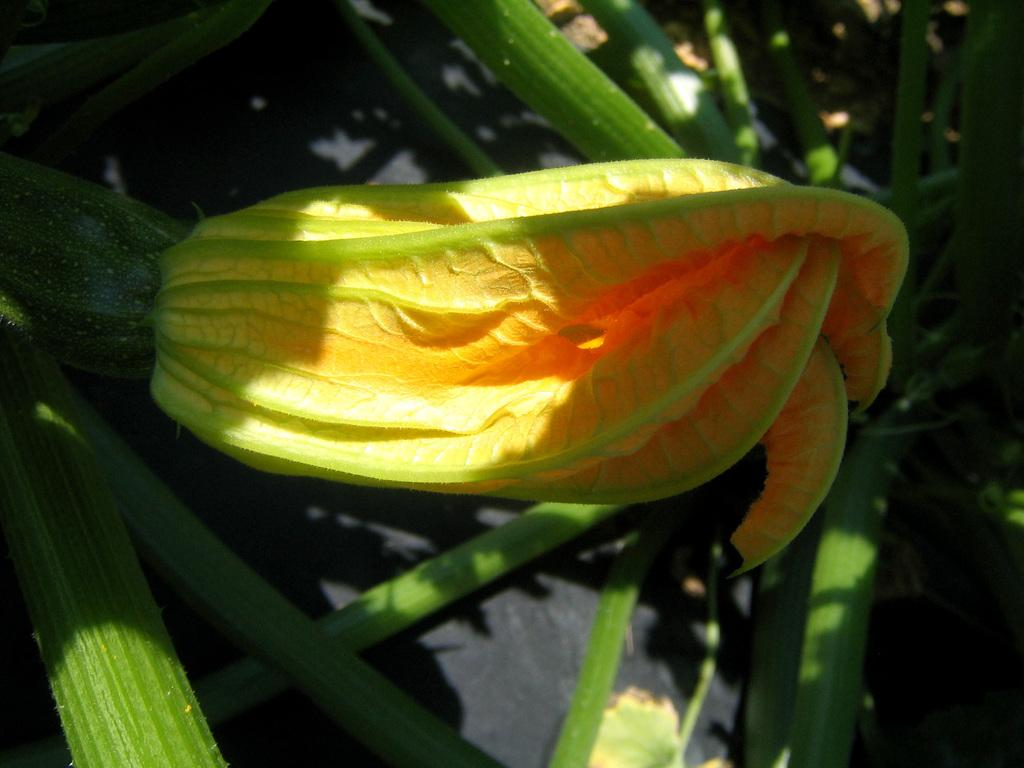What type of plant can be seen in the image? There is a flower in the image, and the stems of a plant are visible. Can you describe the flower in the image? Unfortunately, the specific type of flower cannot be determined from the image alone. What part of the plant is visible in the image? The stems of the plant are visible in the image. What does the caption say about the flower in the image? There is no caption present in the image, so it is not possible to answer that question. 